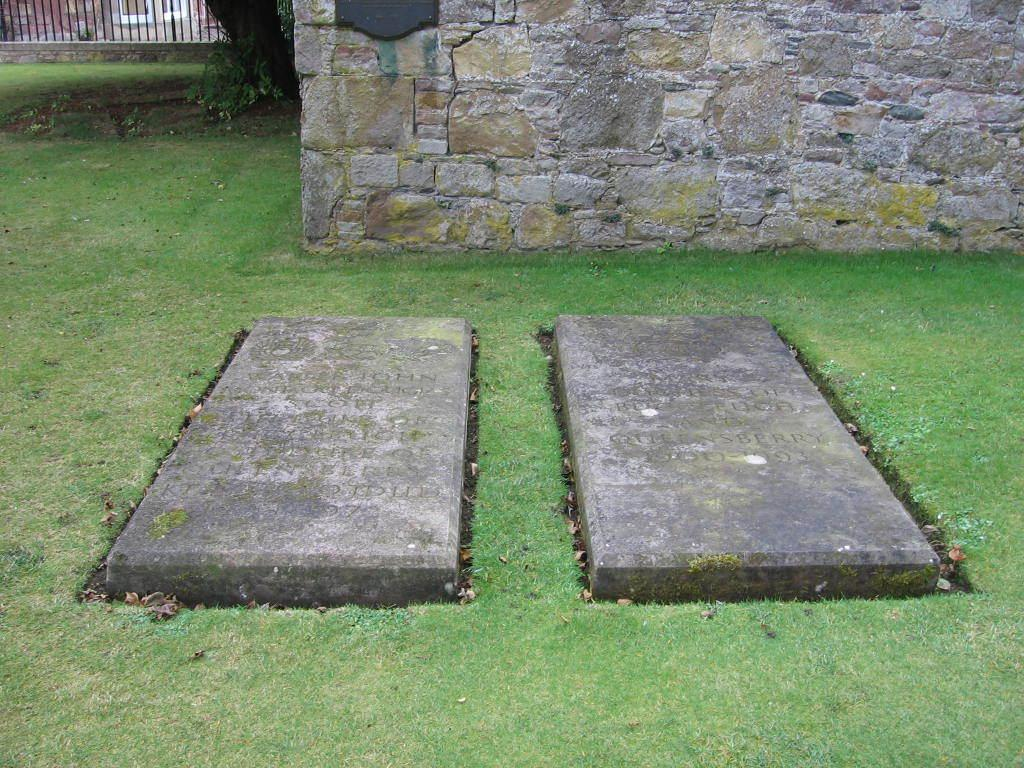What type of structure can be seen in the image? There is a stone wall in the image. What other elements are present in the image? There are railings and a tree trunk in the image. What can be seen at the bottom of the image? The ground is visible at the bottom of the image. Are there any markings or writings in the image? Yes, there are lay stones with text written in the image. What type of trousers are being worn by the tree trunk in the image? There are no trousers present in the image, as the tree trunk is an inanimate object. Is there any snow visible in the image? No, there is no snow present in the image. 